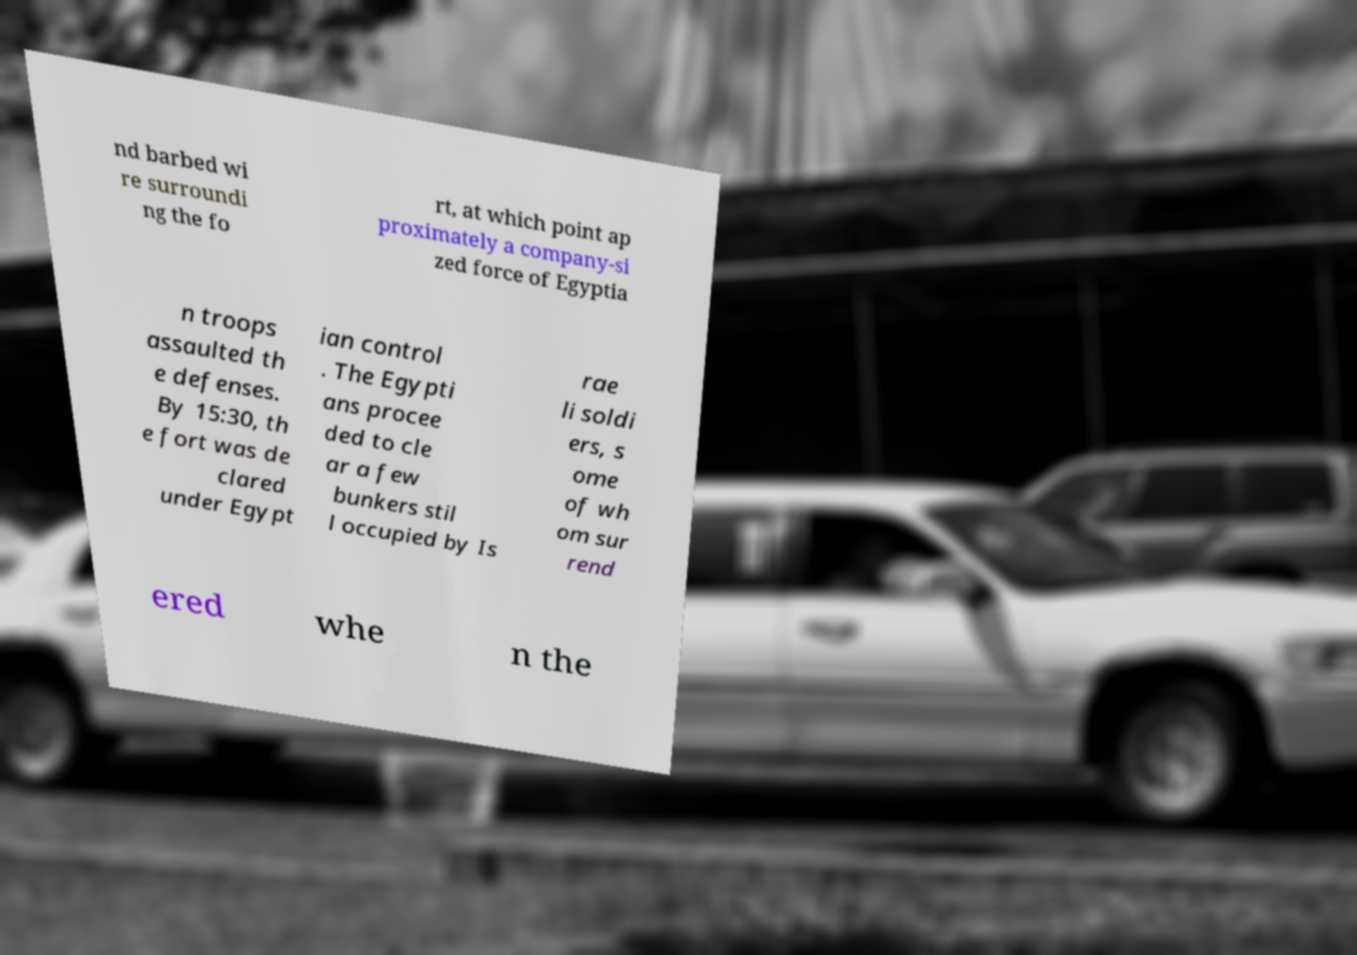Please read and relay the text visible in this image. What does it say? nd barbed wi re surroundi ng the fo rt, at which point ap proximately a company-si zed force of Egyptia n troops assaulted th e defenses. By 15:30, th e fort was de clared under Egypt ian control . The Egypti ans procee ded to cle ar a few bunkers stil l occupied by Is rae li soldi ers, s ome of wh om sur rend ered whe n the 